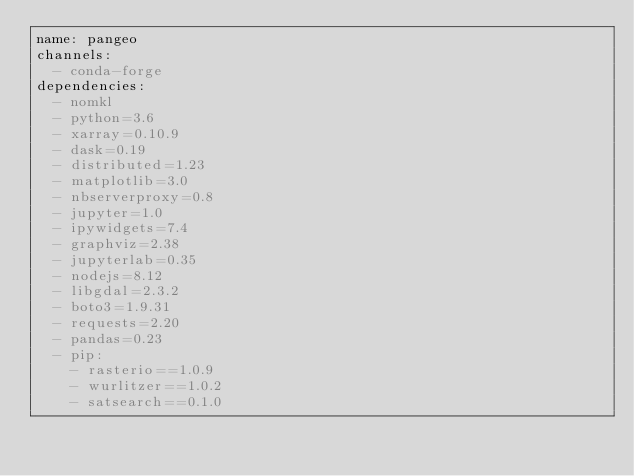Convert code to text. <code><loc_0><loc_0><loc_500><loc_500><_YAML_>name: pangeo
channels:
  - conda-forge
dependencies:
  - nomkl
  - python=3.6
  - xarray=0.10.9
  - dask=0.19
  - distributed=1.23
  - matplotlib=3.0
  - nbserverproxy=0.8
  - jupyter=1.0
  - ipywidgets=7.4
  - graphviz=2.38
  - jupyterlab=0.35
  - nodejs=8.12
  - libgdal=2.3.2
  - boto3=1.9.31
  - requests=2.20
  - pandas=0.23
  - pip:
    - rasterio==1.0.9
    - wurlitzer==1.0.2
    - satsearch==0.1.0
</code> 